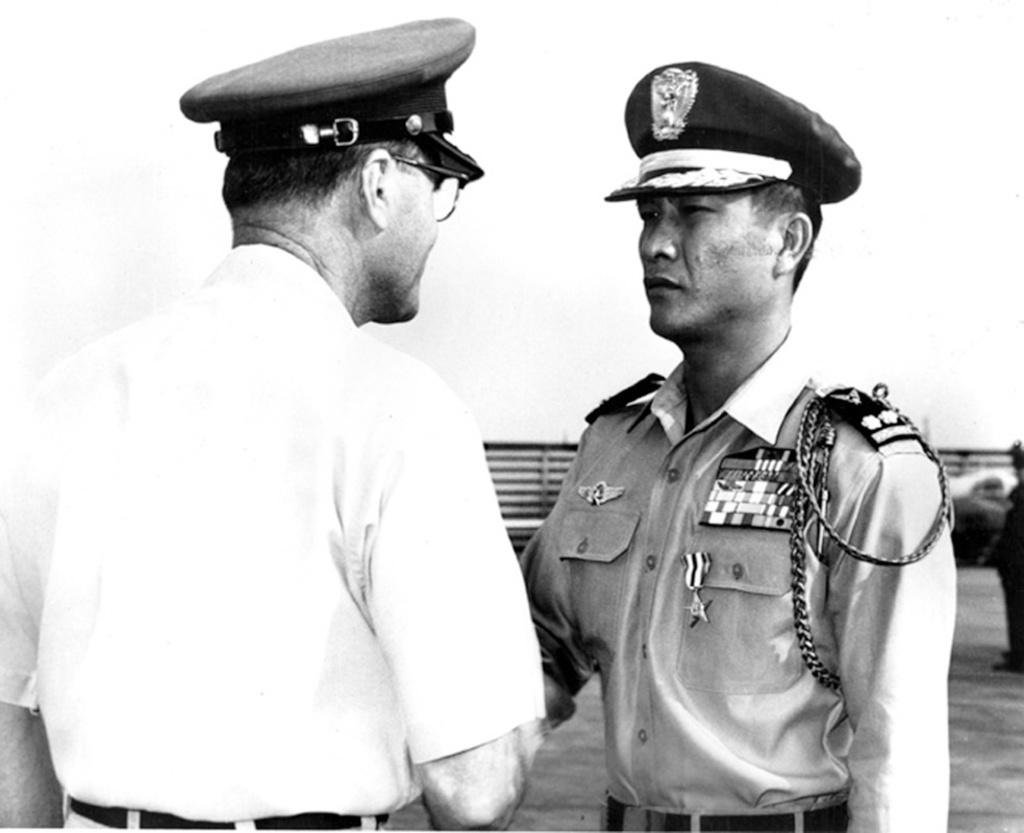What are the people in the image doing? The people in the image are standing in the center. What are the people wearing on their heads? The people are wearing caps. What can be seen in the background of the image? There is a fence in the background of the image. What type of string is being used by the people in the image? There is no string visible in the image; the people are simply standing and wearing caps. 